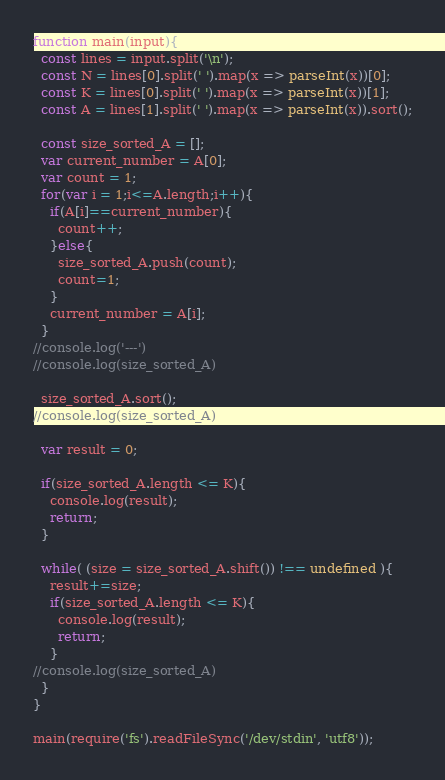Convert code to text. <code><loc_0><loc_0><loc_500><loc_500><_JavaScript_>function main(input){
  const lines = input.split('\n');
  const N = lines[0].split(' ').map(x => parseInt(x))[0];
  const K = lines[0].split(' ').map(x => parseInt(x))[1];
  const A = lines[1].split(' ').map(x => parseInt(x)).sort();

  const size_sorted_A = [];
  var current_number = A[0];
  var count = 1;
  for(var i = 1;i<=A.length;i++){
    if(A[i]==current_number){
      count++;
    }else{
      size_sorted_A.push(count);
      count=1;
    }
    current_number = A[i];
  }
//console.log('---')
//console.log(size_sorted_A)

  size_sorted_A.sort();
//console.log(size_sorted_A)

  var result = 0;

  if(size_sorted_A.length <= K){
    console.log(result);
    return;
  }

  while( (size = size_sorted_A.shift()) !== undefined ){
    result+=size;
    if(size_sorted_A.length <= K){
      console.log(result);
      return;
    }
//console.log(size_sorted_A)
  }
}

main(require('fs').readFileSync('/dev/stdin', 'utf8'));

</code> 